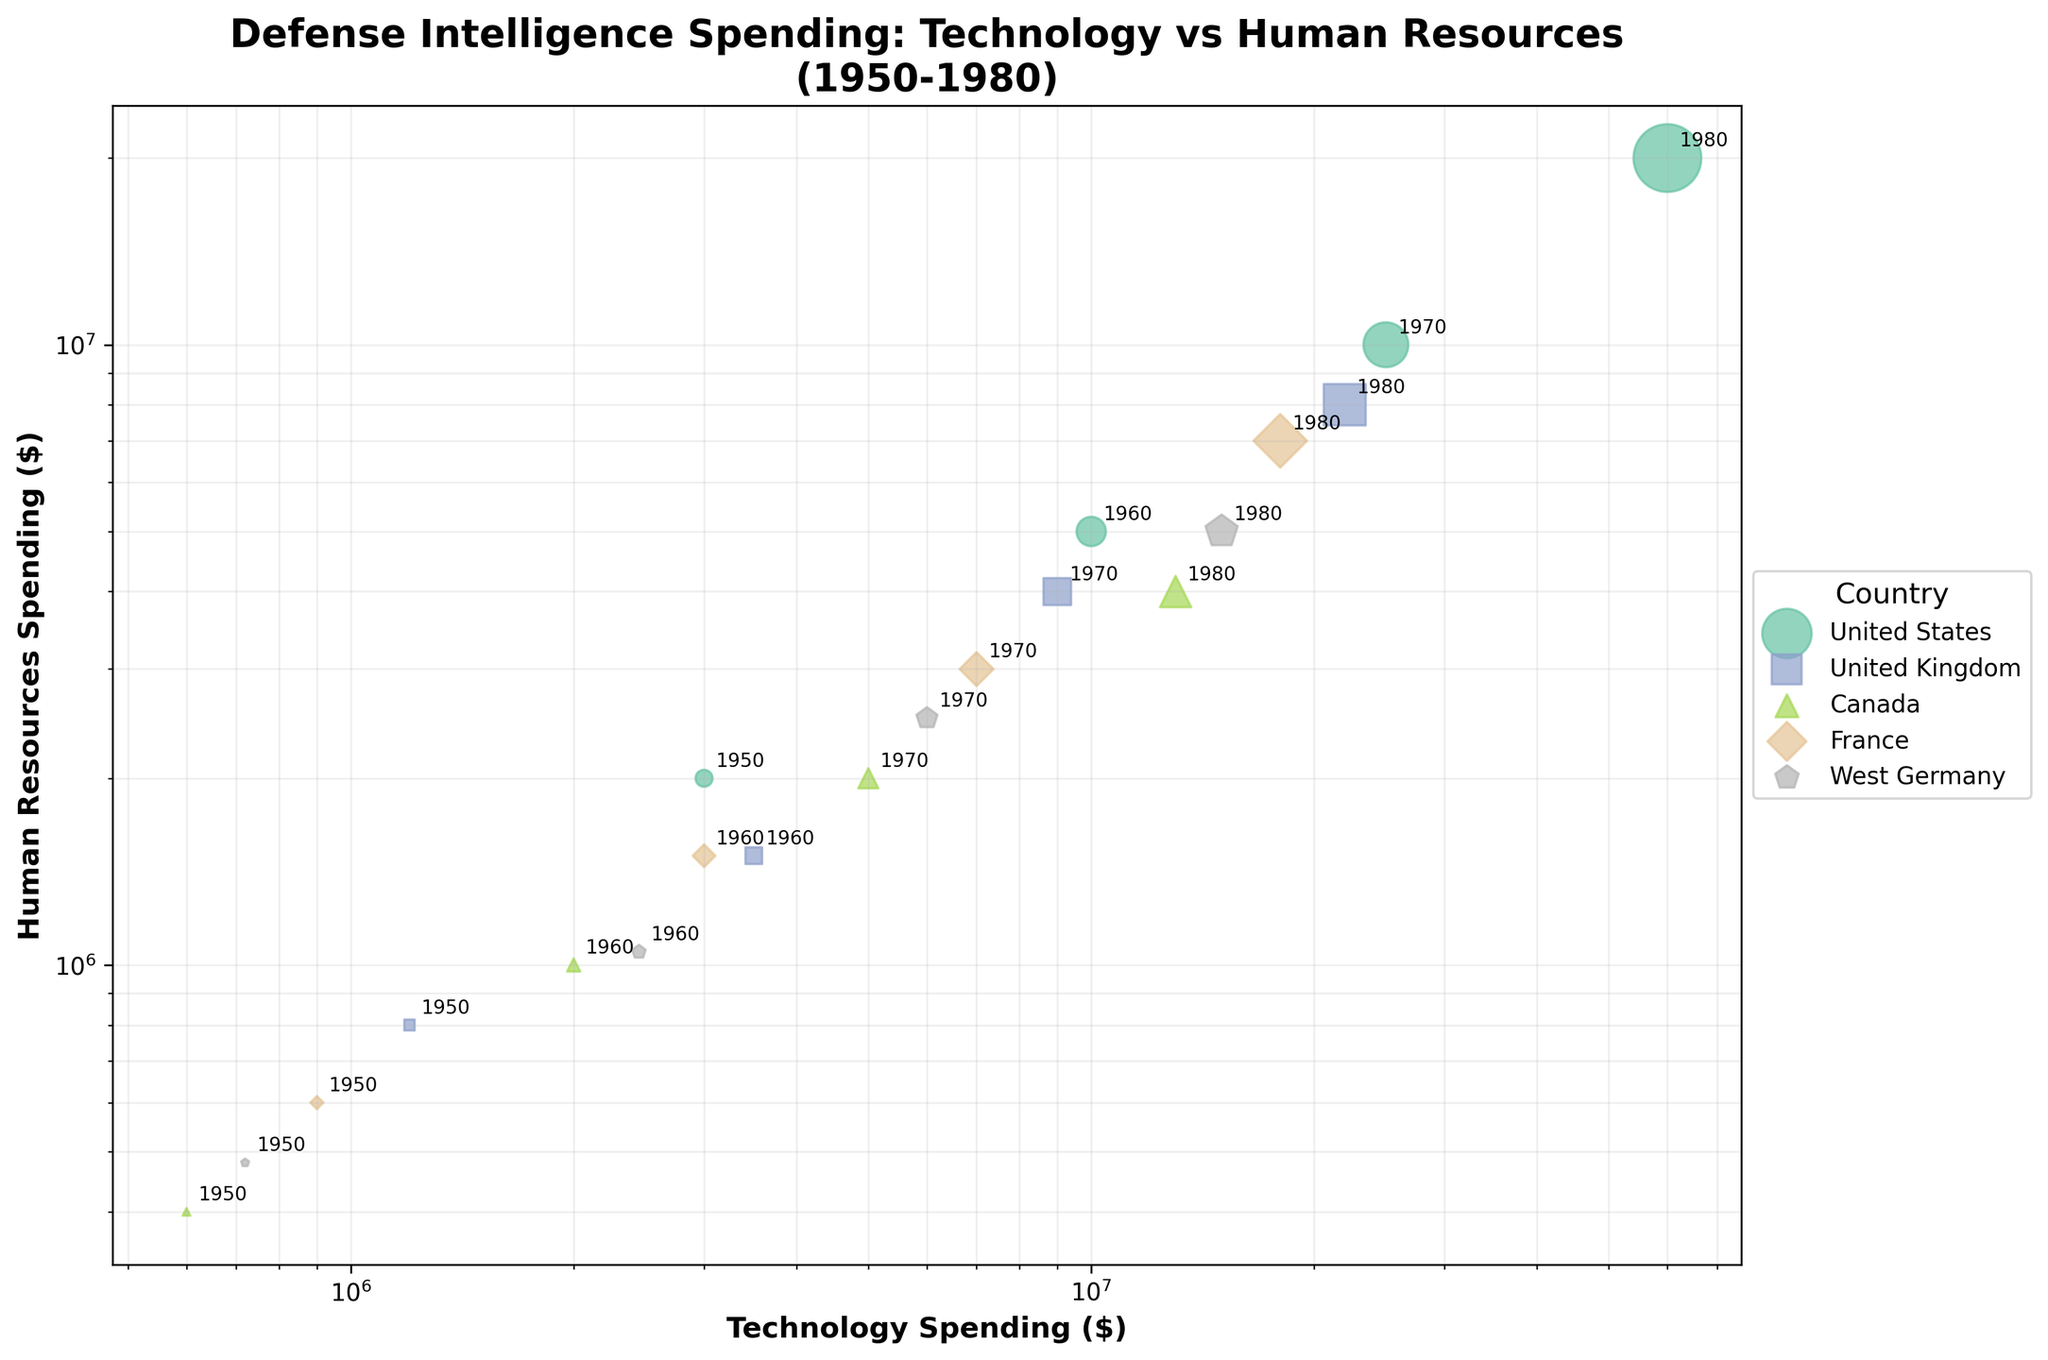How many countries are represented in the scatter plot? The scatter plot uses different colors and markers for each country. Upon inspecting the legend, we can see the number of unique entries.
Answer: 5 What do the sizes of the scatter plot markers represent? The sizes of the markers represent the total defense intelligence spending for each country in a given year. This is evident from the variation in marker sizes and the title which indicates different spending categories.
Answer: Defense intelligence spending Which country had the highest technology spending in 1980? By examining the points for 1980 and matching the highest x-axis value with the respective country in the legend, we can determine the country with the highest technology spending.
Answer: United States What is the relationship between technology spending and human resources spending? Observing the scatter plot, we notice that most points show a positive relationship, indicating that as technology spending increases, human resources spending also tends to increase. This trend is evident as points generally move upwards and to the right.
Answer: Positive correlation Which country shows the largest increase in defense intelligence spending from 1950 to 1980? We look for the country with the largest marker size difference between 1950 and 1980. By comparing the sizes of the markers, the United States shows the highest increase.
Answer: United States On average, is technology or human resources spending higher? Most points appear further to the right (higher technology spending) compared to up (higher human resources spending). This indicates technology spending tends to be higher on average.
Answer: Technology spending Which year has the maximum overall spending for any country, and which country is it? The largest marker indicates the highest overall spending. By inspecting the scatter plot, we identify the largest marker and check its associated country and year label.
Answer: 1980, United States Do any countries spend equally on technology and human resources in any year? Points lying on the 45-degree line (where x = y) indicate equal spending. By examining the plot, we check for any such points.
Answer: No Which country had the least spending on technology in 1950? Look for the smallest x-axis value among the 1950 points and identify the corresponding country by its color and marker style.
Answer: Canada 